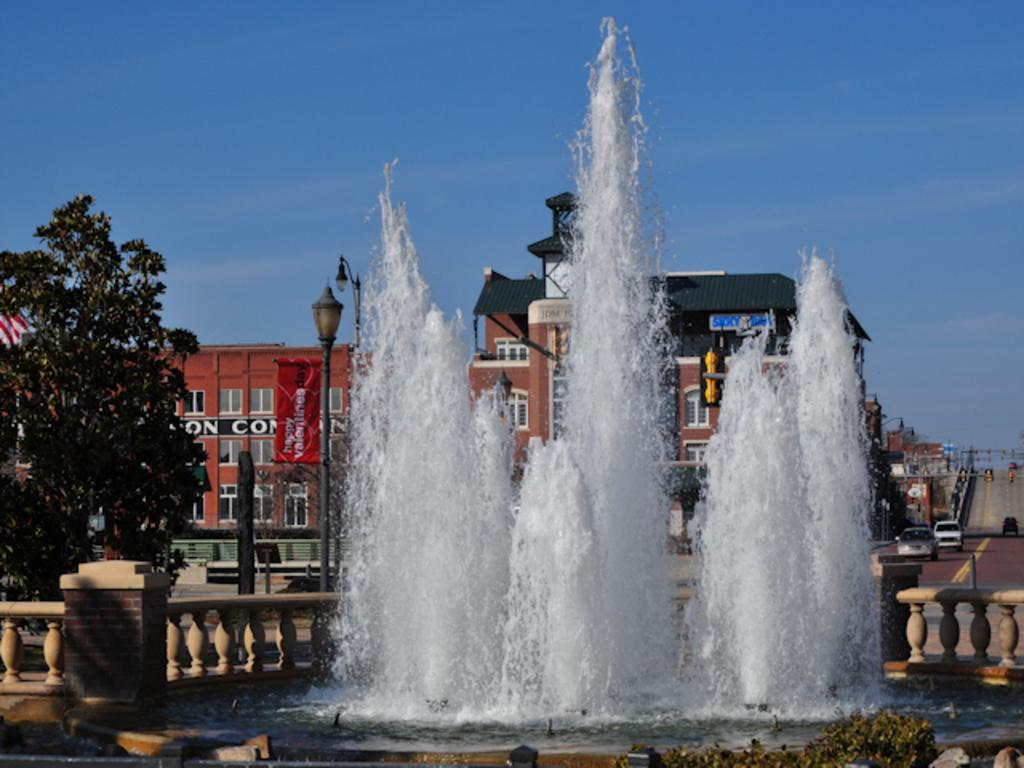What is located in the foreground of the image? There is a water fountain and a fence in the foreground of the image. What can be seen in the background of the image? There are vehicles parked on the road, poles, a building, a tree, and the sky visible in the background of the image. What type of caption is written on the water fountain in the image? There is no caption written on the water fountain in the image. How does the thumb affect the rainstorm in the image? There is no rainstorm or thumb present in the image. 